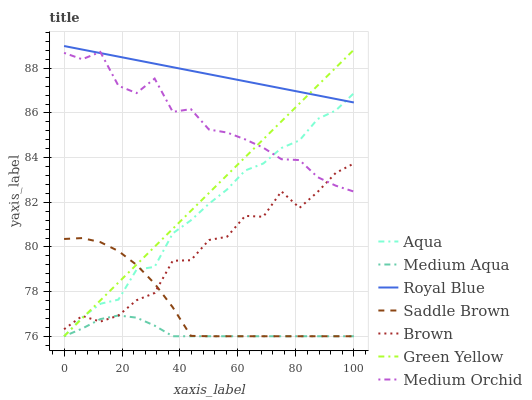Does Medium Aqua have the minimum area under the curve?
Answer yes or no. Yes. Does Royal Blue have the maximum area under the curve?
Answer yes or no. Yes. Does Medium Orchid have the minimum area under the curve?
Answer yes or no. No. Does Medium Orchid have the maximum area under the curve?
Answer yes or no. No. Is Green Yellow the smoothest?
Answer yes or no. Yes. Is Brown the roughest?
Answer yes or no. Yes. Is Medium Orchid the smoothest?
Answer yes or no. No. Is Medium Orchid the roughest?
Answer yes or no. No. Does Aqua have the lowest value?
Answer yes or no. Yes. Does Medium Orchid have the lowest value?
Answer yes or no. No. Does Royal Blue have the highest value?
Answer yes or no. Yes. Does Medium Orchid have the highest value?
Answer yes or no. No. Is Medium Aqua less than Medium Orchid?
Answer yes or no. Yes. Is Medium Orchid greater than Saddle Brown?
Answer yes or no. Yes. Does Green Yellow intersect Aqua?
Answer yes or no. Yes. Is Green Yellow less than Aqua?
Answer yes or no. No. Is Green Yellow greater than Aqua?
Answer yes or no. No. Does Medium Aqua intersect Medium Orchid?
Answer yes or no. No. 